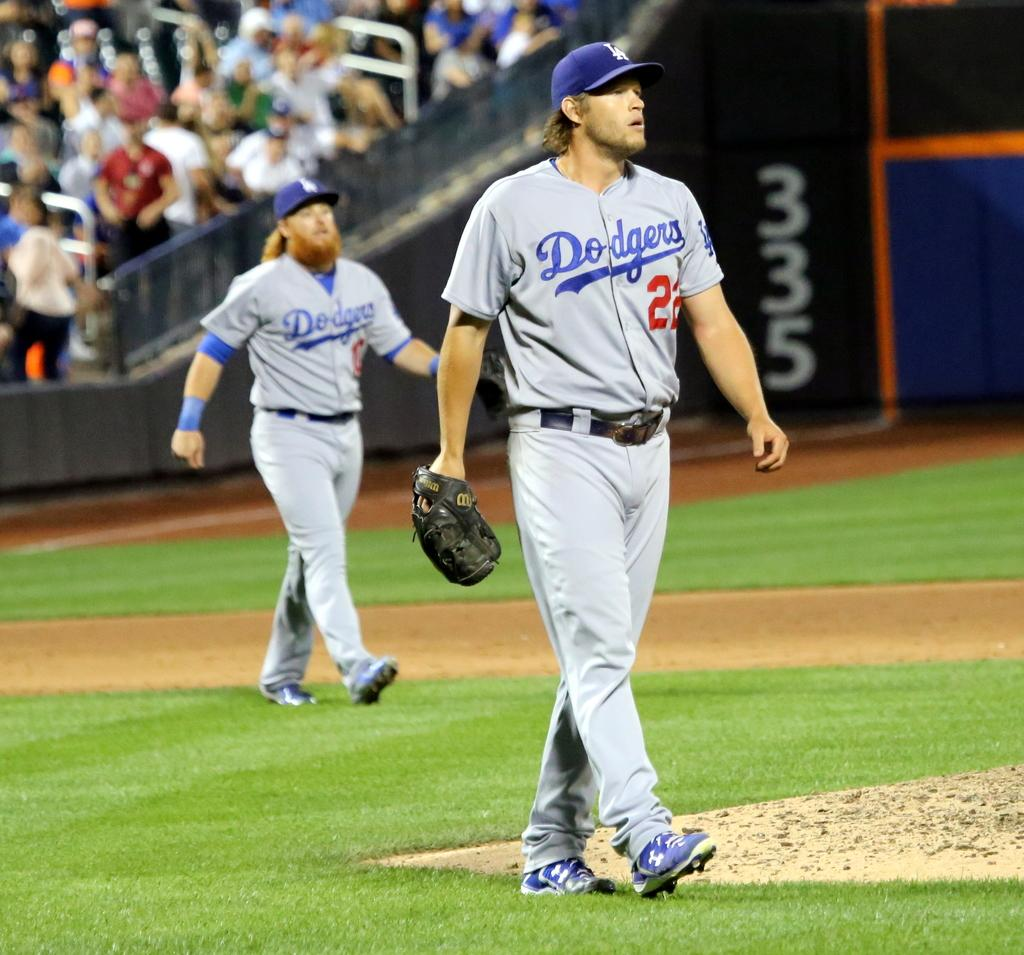<image>
Create a compact narrative representing the image presented. Two baseball players with dodgers unifoms walking down the field. 